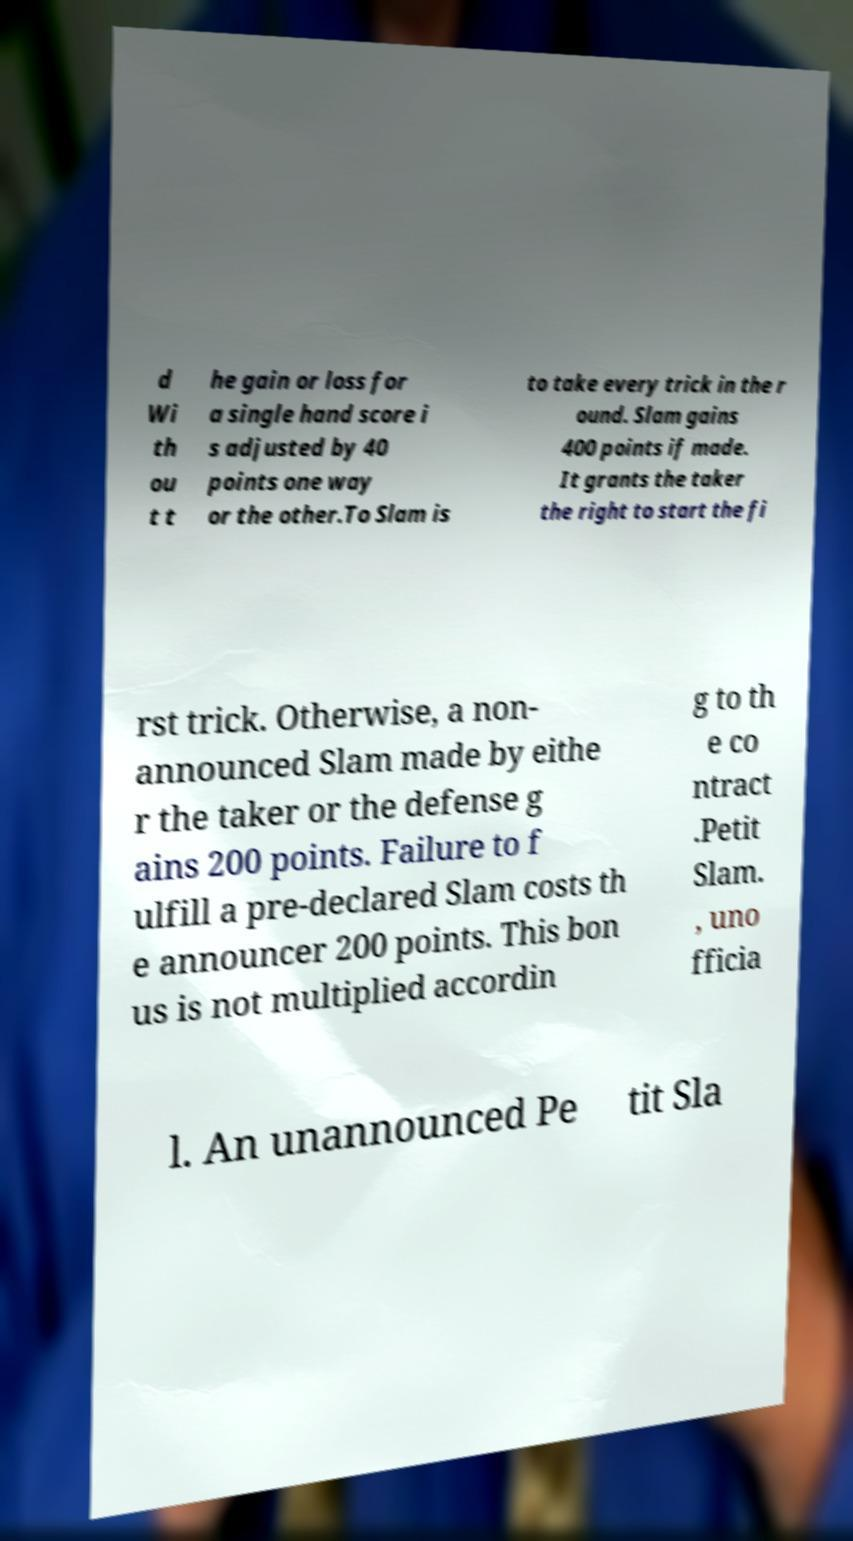Can you read and provide the text displayed in the image?This photo seems to have some interesting text. Can you extract and type it out for me? d Wi th ou t t he gain or loss for a single hand score i s adjusted by 40 points one way or the other.To Slam is to take every trick in the r ound. Slam gains 400 points if made. It grants the taker the right to start the fi rst trick. Otherwise, a non- announced Slam made by eithe r the taker or the defense g ains 200 points. Failure to f ulfill a pre-declared Slam costs th e announcer 200 points. This bon us is not multiplied accordin g to th e co ntract .Petit Slam. , uno fficia l. An unannounced Pe tit Sla 